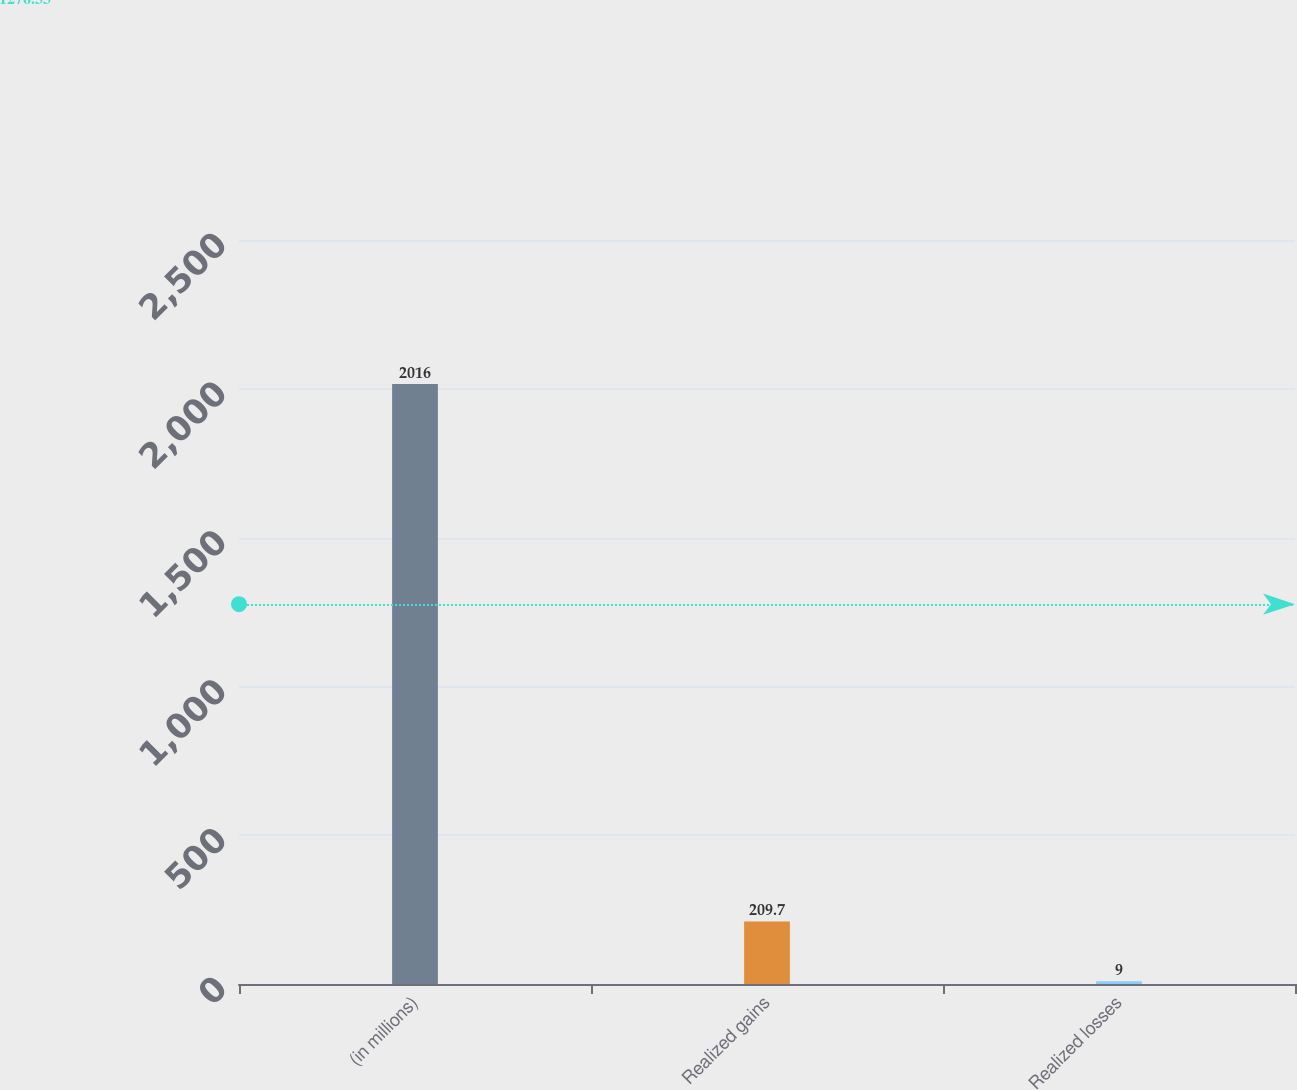<chart> <loc_0><loc_0><loc_500><loc_500><bar_chart><fcel>(in millions)<fcel>Realized gains<fcel>Realized losses<nl><fcel>2016<fcel>209.7<fcel>9<nl></chart> 